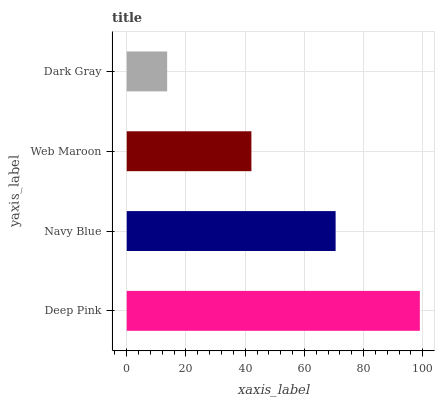Is Dark Gray the minimum?
Answer yes or no. Yes. Is Deep Pink the maximum?
Answer yes or no. Yes. Is Navy Blue the minimum?
Answer yes or no. No. Is Navy Blue the maximum?
Answer yes or no. No. Is Deep Pink greater than Navy Blue?
Answer yes or no. Yes. Is Navy Blue less than Deep Pink?
Answer yes or no. Yes. Is Navy Blue greater than Deep Pink?
Answer yes or no. No. Is Deep Pink less than Navy Blue?
Answer yes or no. No. Is Navy Blue the high median?
Answer yes or no. Yes. Is Web Maroon the low median?
Answer yes or no. Yes. Is Dark Gray the high median?
Answer yes or no. No. Is Dark Gray the low median?
Answer yes or no. No. 